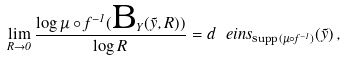<formula> <loc_0><loc_0><loc_500><loc_500>\lim _ { R \to 0 } \frac { \log \mu \circ f ^ { - 1 } ( \text {B} _ { Y } ( \tilde { y } , R ) ) } { \log R } = d \ e i n s _ { \text {supp} ( \mu \circ f ^ { - 1 } ) } ( \tilde { y } ) \, ,</formula> 